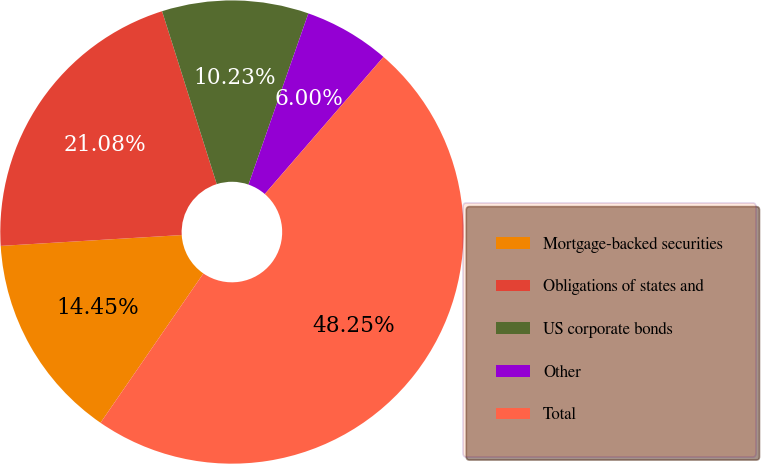Convert chart. <chart><loc_0><loc_0><loc_500><loc_500><pie_chart><fcel>Mortgage-backed securities<fcel>Obligations of states and<fcel>US corporate bonds<fcel>Other<fcel>Total<nl><fcel>14.45%<fcel>21.08%<fcel>10.23%<fcel>6.0%<fcel>48.25%<nl></chart> 